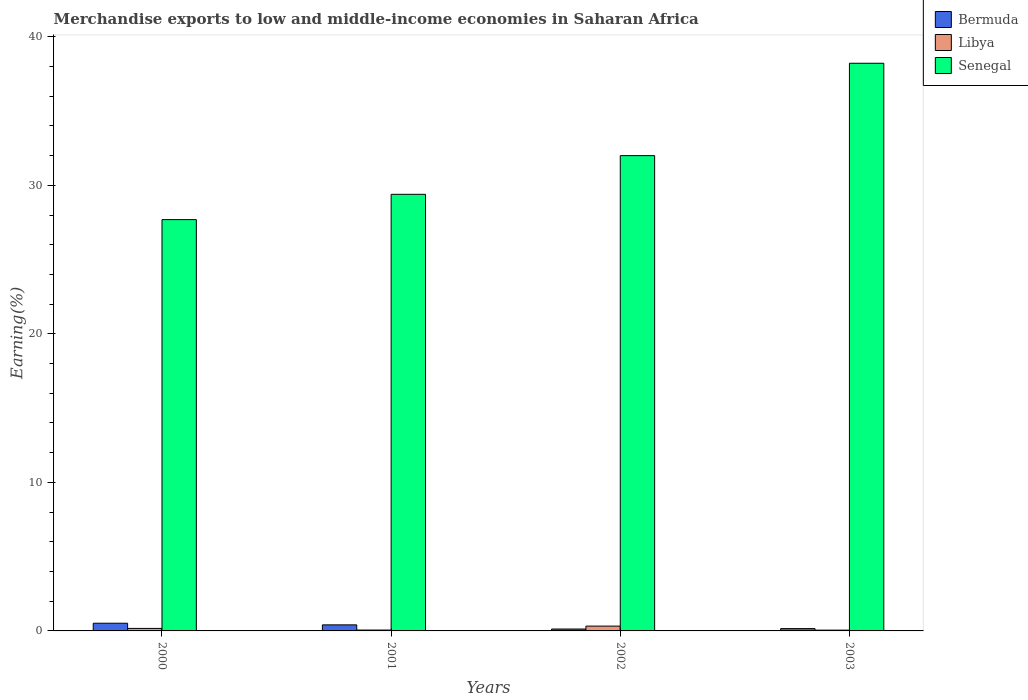How many groups of bars are there?
Your answer should be compact. 4. How many bars are there on the 1st tick from the left?
Ensure brevity in your answer.  3. How many bars are there on the 4th tick from the right?
Ensure brevity in your answer.  3. What is the percentage of amount earned from merchandise exports in Senegal in 2002?
Make the answer very short. 32. Across all years, what is the maximum percentage of amount earned from merchandise exports in Bermuda?
Give a very brief answer. 0.52. Across all years, what is the minimum percentage of amount earned from merchandise exports in Senegal?
Give a very brief answer. 27.69. In which year was the percentage of amount earned from merchandise exports in Bermuda minimum?
Offer a very short reply. 2002. What is the total percentage of amount earned from merchandise exports in Libya in the graph?
Ensure brevity in your answer.  0.6. What is the difference between the percentage of amount earned from merchandise exports in Libya in 2000 and that in 2003?
Provide a succinct answer. 0.12. What is the difference between the percentage of amount earned from merchandise exports in Senegal in 2000 and the percentage of amount earned from merchandise exports in Bermuda in 2003?
Offer a terse response. 27.54. What is the average percentage of amount earned from merchandise exports in Libya per year?
Make the answer very short. 0.15. In the year 2002, what is the difference between the percentage of amount earned from merchandise exports in Bermuda and percentage of amount earned from merchandise exports in Senegal?
Ensure brevity in your answer.  -31.87. In how many years, is the percentage of amount earned from merchandise exports in Libya greater than 8 %?
Your response must be concise. 0. What is the ratio of the percentage of amount earned from merchandise exports in Senegal in 2000 to that in 2001?
Keep it short and to the point. 0.94. What is the difference between the highest and the second highest percentage of amount earned from merchandise exports in Senegal?
Make the answer very short. 6.22. What is the difference between the highest and the lowest percentage of amount earned from merchandise exports in Bermuda?
Your answer should be very brief. 0.39. In how many years, is the percentage of amount earned from merchandise exports in Bermuda greater than the average percentage of amount earned from merchandise exports in Bermuda taken over all years?
Your response must be concise. 2. What does the 2nd bar from the left in 2000 represents?
Offer a terse response. Libya. What does the 1st bar from the right in 2002 represents?
Your answer should be very brief. Senegal. Are all the bars in the graph horizontal?
Offer a terse response. No. Are the values on the major ticks of Y-axis written in scientific E-notation?
Offer a very short reply. No. Does the graph contain any zero values?
Provide a succinct answer. No. Where does the legend appear in the graph?
Keep it short and to the point. Top right. How many legend labels are there?
Offer a terse response. 3. How are the legend labels stacked?
Your answer should be very brief. Vertical. What is the title of the graph?
Ensure brevity in your answer.  Merchandise exports to low and middle-income economies in Saharan Africa. Does "Cabo Verde" appear as one of the legend labels in the graph?
Your answer should be compact. No. What is the label or title of the X-axis?
Keep it short and to the point. Years. What is the label or title of the Y-axis?
Provide a succinct answer. Earning(%). What is the Earning(%) in Bermuda in 2000?
Provide a succinct answer. 0.52. What is the Earning(%) of Libya in 2000?
Offer a terse response. 0.17. What is the Earning(%) in Senegal in 2000?
Offer a terse response. 27.69. What is the Earning(%) in Bermuda in 2001?
Provide a short and direct response. 0.41. What is the Earning(%) of Libya in 2001?
Your response must be concise. 0.06. What is the Earning(%) of Senegal in 2001?
Ensure brevity in your answer.  29.4. What is the Earning(%) in Bermuda in 2002?
Your answer should be compact. 0.13. What is the Earning(%) of Libya in 2002?
Provide a succinct answer. 0.32. What is the Earning(%) of Senegal in 2002?
Your answer should be compact. 32. What is the Earning(%) in Bermuda in 2003?
Your response must be concise. 0.16. What is the Earning(%) in Libya in 2003?
Your answer should be compact. 0.05. What is the Earning(%) of Senegal in 2003?
Keep it short and to the point. 38.22. Across all years, what is the maximum Earning(%) in Bermuda?
Your answer should be very brief. 0.52. Across all years, what is the maximum Earning(%) of Libya?
Your answer should be compact. 0.32. Across all years, what is the maximum Earning(%) in Senegal?
Your answer should be very brief. 38.22. Across all years, what is the minimum Earning(%) of Bermuda?
Offer a very short reply. 0.13. Across all years, what is the minimum Earning(%) of Libya?
Keep it short and to the point. 0.05. Across all years, what is the minimum Earning(%) of Senegal?
Your answer should be compact. 27.69. What is the total Earning(%) of Bermuda in the graph?
Keep it short and to the point. 1.21. What is the total Earning(%) of Libya in the graph?
Make the answer very short. 0.6. What is the total Earning(%) of Senegal in the graph?
Keep it short and to the point. 127.32. What is the difference between the Earning(%) of Bermuda in 2000 and that in 2001?
Provide a short and direct response. 0.11. What is the difference between the Earning(%) of Libya in 2000 and that in 2001?
Offer a very short reply. 0.11. What is the difference between the Earning(%) of Senegal in 2000 and that in 2001?
Offer a terse response. -1.7. What is the difference between the Earning(%) in Bermuda in 2000 and that in 2002?
Provide a short and direct response. 0.39. What is the difference between the Earning(%) of Libya in 2000 and that in 2002?
Keep it short and to the point. -0.16. What is the difference between the Earning(%) of Senegal in 2000 and that in 2002?
Provide a short and direct response. -4.31. What is the difference between the Earning(%) in Bermuda in 2000 and that in 2003?
Your response must be concise. 0.36. What is the difference between the Earning(%) of Libya in 2000 and that in 2003?
Offer a terse response. 0.12. What is the difference between the Earning(%) in Senegal in 2000 and that in 2003?
Offer a very short reply. -10.53. What is the difference between the Earning(%) of Bermuda in 2001 and that in 2002?
Keep it short and to the point. 0.28. What is the difference between the Earning(%) in Libya in 2001 and that in 2002?
Ensure brevity in your answer.  -0.27. What is the difference between the Earning(%) in Senegal in 2001 and that in 2002?
Your answer should be very brief. -2.6. What is the difference between the Earning(%) of Bermuda in 2001 and that in 2003?
Give a very brief answer. 0.25. What is the difference between the Earning(%) in Libya in 2001 and that in 2003?
Your answer should be compact. 0.01. What is the difference between the Earning(%) of Senegal in 2001 and that in 2003?
Ensure brevity in your answer.  -8.82. What is the difference between the Earning(%) of Bermuda in 2002 and that in 2003?
Provide a succinct answer. -0.03. What is the difference between the Earning(%) of Libya in 2002 and that in 2003?
Make the answer very short. 0.27. What is the difference between the Earning(%) of Senegal in 2002 and that in 2003?
Keep it short and to the point. -6.22. What is the difference between the Earning(%) of Bermuda in 2000 and the Earning(%) of Libya in 2001?
Keep it short and to the point. 0.46. What is the difference between the Earning(%) of Bermuda in 2000 and the Earning(%) of Senegal in 2001?
Provide a succinct answer. -28.88. What is the difference between the Earning(%) in Libya in 2000 and the Earning(%) in Senegal in 2001?
Provide a short and direct response. -29.23. What is the difference between the Earning(%) in Bermuda in 2000 and the Earning(%) in Libya in 2002?
Your answer should be compact. 0.19. What is the difference between the Earning(%) of Bermuda in 2000 and the Earning(%) of Senegal in 2002?
Give a very brief answer. -31.48. What is the difference between the Earning(%) of Libya in 2000 and the Earning(%) of Senegal in 2002?
Offer a very short reply. -31.83. What is the difference between the Earning(%) of Bermuda in 2000 and the Earning(%) of Libya in 2003?
Offer a terse response. 0.47. What is the difference between the Earning(%) of Bermuda in 2000 and the Earning(%) of Senegal in 2003?
Ensure brevity in your answer.  -37.7. What is the difference between the Earning(%) of Libya in 2000 and the Earning(%) of Senegal in 2003?
Give a very brief answer. -38.05. What is the difference between the Earning(%) of Bermuda in 2001 and the Earning(%) of Libya in 2002?
Provide a succinct answer. 0.08. What is the difference between the Earning(%) of Bermuda in 2001 and the Earning(%) of Senegal in 2002?
Your answer should be very brief. -31.59. What is the difference between the Earning(%) in Libya in 2001 and the Earning(%) in Senegal in 2002?
Your answer should be very brief. -31.94. What is the difference between the Earning(%) of Bermuda in 2001 and the Earning(%) of Libya in 2003?
Offer a terse response. 0.35. What is the difference between the Earning(%) of Bermuda in 2001 and the Earning(%) of Senegal in 2003?
Your response must be concise. -37.81. What is the difference between the Earning(%) of Libya in 2001 and the Earning(%) of Senegal in 2003?
Provide a short and direct response. -38.16. What is the difference between the Earning(%) of Bermuda in 2002 and the Earning(%) of Libya in 2003?
Your answer should be compact. 0.08. What is the difference between the Earning(%) of Bermuda in 2002 and the Earning(%) of Senegal in 2003?
Offer a terse response. -38.09. What is the difference between the Earning(%) of Libya in 2002 and the Earning(%) of Senegal in 2003?
Ensure brevity in your answer.  -37.9. What is the average Earning(%) of Bermuda per year?
Provide a short and direct response. 0.3. What is the average Earning(%) in Libya per year?
Give a very brief answer. 0.15. What is the average Earning(%) of Senegal per year?
Your answer should be compact. 31.83. In the year 2000, what is the difference between the Earning(%) in Bermuda and Earning(%) in Libya?
Your response must be concise. 0.35. In the year 2000, what is the difference between the Earning(%) in Bermuda and Earning(%) in Senegal?
Offer a very short reply. -27.18. In the year 2000, what is the difference between the Earning(%) in Libya and Earning(%) in Senegal?
Make the answer very short. -27.53. In the year 2001, what is the difference between the Earning(%) in Bermuda and Earning(%) in Libya?
Give a very brief answer. 0.35. In the year 2001, what is the difference between the Earning(%) in Bermuda and Earning(%) in Senegal?
Provide a short and direct response. -28.99. In the year 2001, what is the difference between the Earning(%) in Libya and Earning(%) in Senegal?
Provide a short and direct response. -29.34. In the year 2002, what is the difference between the Earning(%) in Bermuda and Earning(%) in Libya?
Your answer should be very brief. -0.2. In the year 2002, what is the difference between the Earning(%) in Bermuda and Earning(%) in Senegal?
Keep it short and to the point. -31.87. In the year 2002, what is the difference between the Earning(%) in Libya and Earning(%) in Senegal?
Your answer should be very brief. -31.68. In the year 2003, what is the difference between the Earning(%) of Bermuda and Earning(%) of Libya?
Provide a succinct answer. 0.1. In the year 2003, what is the difference between the Earning(%) in Bermuda and Earning(%) in Senegal?
Offer a terse response. -38.07. In the year 2003, what is the difference between the Earning(%) of Libya and Earning(%) of Senegal?
Offer a very short reply. -38.17. What is the ratio of the Earning(%) in Bermuda in 2000 to that in 2001?
Your response must be concise. 1.27. What is the ratio of the Earning(%) of Libya in 2000 to that in 2001?
Keep it short and to the point. 2.88. What is the ratio of the Earning(%) of Senegal in 2000 to that in 2001?
Keep it short and to the point. 0.94. What is the ratio of the Earning(%) of Bermuda in 2000 to that in 2002?
Offer a very short reply. 4.05. What is the ratio of the Earning(%) of Libya in 2000 to that in 2002?
Provide a succinct answer. 0.52. What is the ratio of the Earning(%) of Senegal in 2000 to that in 2002?
Your response must be concise. 0.87. What is the ratio of the Earning(%) of Bermuda in 2000 to that in 2003?
Ensure brevity in your answer.  3.33. What is the ratio of the Earning(%) of Libya in 2000 to that in 2003?
Provide a succinct answer. 3.19. What is the ratio of the Earning(%) of Senegal in 2000 to that in 2003?
Keep it short and to the point. 0.72. What is the ratio of the Earning(%) of Bermuda in 2001 to that in 2002?
Your response must be concise. 3.18. What is the ratio of the Earning(%) of Libya in 2001 to that in 2002?
Your answer should be very brief. 0.18. What is the ratio of the Earning(%) of Senegal in 2001 to that in 2002?
Your answer should be compact. 0.92. What is the ratio of the Earning(%) in Bermuda in 2001 to that in 2003?
Give a very brief answer. 2.62. What is the ratio of the Earning(%) in Libya in 2001 to that in 2003?
Your answer should be very brief. 1.11. What is the ratio of the Earning(%) in Senegal in 2001 to that in 2003?
Your answer should be compact. 0.77. What is the ratio of the Earning(%) in Bermuda in 2002 to that in 2003?
Ensure brevity in your answer.  0.82. What is the ratio of the Earning(%) in Libya in 2002 to that in 2003?
Your answer should be very brief. 6.12. What is the ratio of the Earning(%) in Senegal in 2002 to that in 2003?
Provide a succinct answer. 0.84. What is the difference between the highest and the second highest Earning(%) in Bermuda?
Your response must be concise. 0.11. What is the difference between the highest and the second highest Earning(%) of Libya?
Give a very brief answer. 0.16. What is the difference between the highest and the second highest Earning(%) in Senegal?
Keep it short and to the point. 6.22. What is the difference between the highest and the lowest Earning(%) in Bermuda?
Give a very brief answer. 0.39. What is the difference between the highest and the lowest Earning(%) in Libya?
Ensure brevity in your answer.  0.27. What is the difference between the highest and the lowest Earning(%) in Senegal?
Make the answer very short. 10.53. 